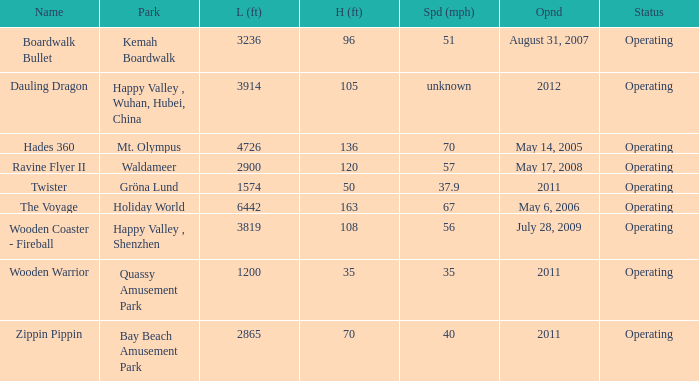What is the length of the coaster with the unknown speed 3914.0. 